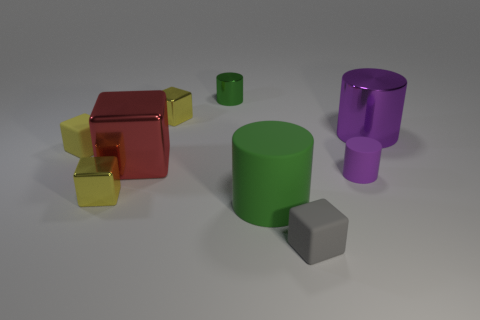Can you tell me how many objects are in the image and what their shapes are? There are seven objects in the image, comprised of different shapes: one large red cube, one small yellow cube, one large green cylinder, one small green cylinder, one large purple cylinder, one purple cone, and one gray hexahedron. 